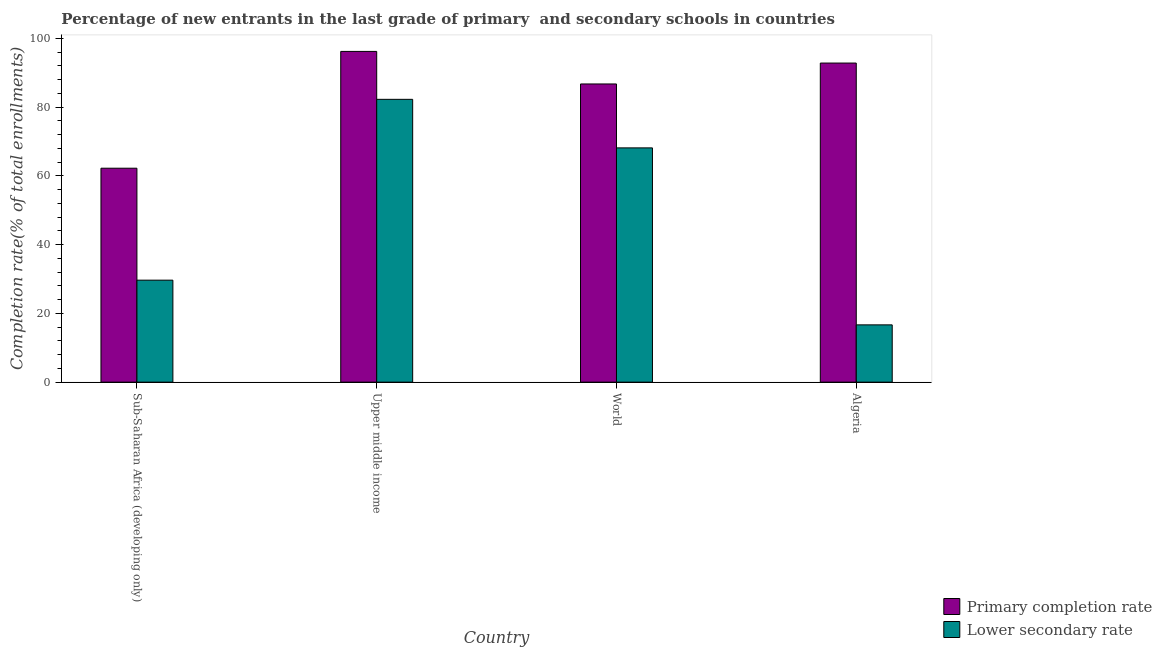How many different coloured bars are there?
Provide a succinct answer. 2. Are the number of bars per tick equal to the number of legend labels?
Give a very brief answer. Yes. What is the label of the 2nd group of bars from the left?
Provide a short and direct response. Upper middle income. What is the completion rate in primary schools in Sub-Saharan Africa (developing only)?
Ensure brevity in your answer.  62.25. Across all countries, what is the maximum completion rate in secondary schools?
Provide a succinct answer. 82.3. Across all countries, what is the minimum completion rate in primary schools?
Ensure brevity in your answer.  62.25. In which country was the completion rate in secondary schools maximum?
Provide a short and direct response. Upper middle income. In which country was the completion rate in secondary schools minimum?
Your answer should be very brief. Algeria. What is the total completion rate in primary schools in the graph?
Provide a succinct answer. 338.13. What is the difference between the completion rate in primary schools in Algeria and that in Sub-Saharan Africa (developing only)?
Keep it short and to the point. 30.6. What is the difference between the completion rate in secondary schools in Sub-Saharan Africa (developing only) and the completion rate in primary schools in World?
Make the answer very short. -57.1. What is the average completion rate in secondary schools per country?
Ensure brevity in your answer.  49.2. What is the difference between the completion rate in primary schools and completion rate in secondary schools in Upper middle income?
Offer a very short reply. 13.95. What is the ratio of the completion rate in secondary schools in Algeria to that in Upper middle income?
Provide a short and direct response. 0.2. Is the difference between the completion rate in secondary schools in Algeria and Sub-Saharan Africa (developing only) greater than the difference between the completion rate in primary schools in Algeria and Sub-Saharan Africa (developing only)?
Provide a short and direct response. No. What is the difference between the highest and the second highest completion rate in primary schools?
Offer a very short reply. 3.39. What is the difference between the highest and the lowest completion rate in secondary schools?
Your answer should be compact. 65.63. In how many countries, is the completion rate in secondary schools greater than the average completion rate in secondary schools taken over all countries?
Provide a short and direct response. 2. Is the sum of the completion rate in primary schools in Sub-Saharan Africa (developing only) and Upper middle income greater than the maximum completion rate in secondary schools across all countries?
Make the answer very short. Yes. What does the 1st bar from the left in World represents?
Your response must be concise. Primary completion rate. What does the 2nd bar from the right in World represents?
Your answer should be compact. Primary completion rate. How many countries are there in the graph?
Your answer should be very brief. 4. Where does the legend appear in the graph?
Provide a short and direct response. Bottom right. How many legend labels are there?
Offer a terse response. 2. What is the title of the graph?
Your answer should be compact. Percentage of new entrants in the last grade of primary  and secondary schools in countries. Does "Taxes" appear as one of the legend labels in the graph?
Provide a short and direct response. No. What is the label or title of the X-axis?
Give a very brief answer. Country. What is the label or title of the Y-axis?
Provide a succinct answer. Completion rate(% of total enrollments). What is the Completion rate(% of total enrollments) in Primary completion rate in Sub-Saharan Africa (developing only)?
Your answer should be compact. 62.25. What is the Completion rate(% of total enrollments) in Lower secondary rate in Sub-Saharan Africa (developing only)?
Offer a very short reply. 29.68. What is the Completion rate(% of total enrollments) of Primary completion rate in Upper middle income?
Offer a very short reply. 96.24. What is the Completion rate(% of total enrollments) of Lower secondary rate in Upper middle income?
Provide a short and direct response. 82.3. What is the Completion rate(% of total enrollments) in Primary completion rate in World?
Provide a succinct answer. 86.77. What is the Completion rate(% of total enrollments) in Lower secondary rate in World?
Give a very brief answer. 68.17. What is the Completion rate(% of total enrollments) of Primary completion rate in Algeria?
Keep it short and to the point. 92.86. What is the Completion rate(% of total enrollments) in Lower secondary rate in Algeria?
Offer a terse response. 16.67. Across all countries, what is the maximum Completion rate(% of total enrollments) in Primary completion rate?
Make the answer very short. 96.24. Across all countries, what is the maximum Completion rate(% of total enrollments) in Lower secondary rate?
Offer a terse response. 82.3. Across all countries, what is the minimum Completion rate(% of total enrollments) in Primary completion rate?
Keep it short and to the point. 62.25. Across all countries, what is the minimum Completion rate(% of total enrollments) of Lower secondary rate?
Give a very brief answer. 16.67. What is the total Completion rate(% of total enrollments) of Primary completion rate in the graph?
Ensure brevity in your answer.  338.13. What is the total Completion rate(% of total enrollments) of Lower secondary rate in the graph?
Offer a very short reply. 196.82. What is the difference between the Completion rate(% of total enrollments) in Primary completion rate in Sub-Saharan Africa (developing only) and that in Upper middle income?
Give a very brief answer. -33.99. What is the difference between the Completion rate(% of total enrollments) in Lower secondary rate in Sub-Saharan Africa (developing only) and that in Upper middle income?
Make the answer very short. -52.62. What is the difference between the Completion rate(% of total enrollments) in Primary completion rate in Sub-Saharan Africa (developing only) and that in World?
Give a very brief answer. -24.52. What is the difference between the Completion rate(% of total enrollments) of Lower secondary rate in Sub-Saharan Africa (developing only) and that in World?
Keep it short and to the point. -38.5. What is the difference between the Completion rate(% of total enrollments) of Primary completion rate in Sub-Saharan Africa (developing only) and that in Algeria?
Provide a short and direct response. -30.6. What is the difference between the Completion rate(% of total enrollments) in Lower secondary rate in Sub-Saharan Africa (developing only) and that in Algeria?
Give a very brief answer. 13.01. What is the difference between the Completion rate(% of total enrollments) in Primary completion rate in Upper middle income and that in World?
Your response must be concise. 9.47. What is the difference between the Completion rate(% of total enrollments) in Lower secondary rate in Upper middle income and that in World?
Keep it short and to the point. 14.13. What is the difference between the Completion rate(% of total enrollments) in Primary completion rate in Upper middle income and that in Algeria?
Keep it short and to the point. 3.39. What is the difference between the Completion rate(% of total enrollments) of Lower secondary rate in Upper middle income and that in Algeria?
Ensure brevity in your answer.  65.63. What is the difference between the Completion rate(% of total enrollments) in Primary completion rate in World and that in Algeria?
Give a very brief answer. -6.08. What is the difference between the Completion rate(% of total enrollments) of Lower secondary rate in World and that in Algeria?
Offer a very short reply. 51.5. What is the difference between the Completion rate(% of total enrollments) of Primary completion rate in Sub-Saharan Africa (developing only) and the Completion rate(% of total enrollments) of Lower secondary rate in Upper middle income?
Your answer should be compact. -20.04. What is the difference between the Completion rate(% of total enrollments) of Primary completion rate in Sub-Saharan Africa (developing only) and the Completion rate(% of total enrollments) of Lower secondary rate in World?
Offer a terse response. -5.92. What is the difference between the Completion rate(% of total enrollments) in Primary completion rate in Sub-Saharan Africa (developing only) and the Completion rate(% of total enrollments) in Lower secondary rate in Algeria?
Offer a terse response. 45.58. What is the difference between the Completion rate(% of total enrollments) of Primary completion rate in Upper middle income and the Completion rate(% of total enrollments) of Lower secondary rate in World?
Your answer should be compact. 28.07. What is the difference between the Completion rate(% of total enrollments) in Primary completion rate in Upper middle income and the Completion rate(% of total enrollments) in Lower secondary rate in Algeria?
Your response must be concise. 79.57. What is the difference between the Completion rate(% of total enrollments) of Primary completion rate in World and the Completion rate(% of total enrollments) of Lower secondary rate in Algeria?
Offer a very short reply. 70.1. What is the average Completion rate(% of total enrollments) in Primary completion rate per country?
Ensure brevity in your answer.  84.53. What is the average Completion rate(% of total enrollments) of Lower secondary rate per country?
Provide a succinct answer. 49.2. What is the difference between the Completion rate(% of total enrollments) of Primary completion rate and Completion rate(% of total enrollments) of Lower secondary rate in Sub-Saharan Africa (developing only)?
Ensure brevity in your answer.  32.58. What is the difference between the Completion rate(% of total enrollments) in Primary completion rate and Completion rate(% of total enrollments) in Lower secondary rate in Upper middle income?
Provide a short and direct response. 13.95. What is the difference between the Completion rate(% of total enrollments) of Primary completion rate and Completion rate(% of total enrollments) of Lower secondary rate in World?
Give a very brief answer. 18.6. What is the difference between the Completion rate(% of total enrollments) in Primary completion rate and Completion rate(% of total enrollments) in Lower secondary rate in Algeria?
Offer a very short reply. 76.19. What is the ratio of the Completion rate(% of total enrollments) in Primary completion rate in Sub-Saharan Africa (developing only) to that in Upper middle income?
Make the answer very short. 0.65. What is the ratio of the Completion rate(% of total enrollments) of Lower secondary rate in Sub-Saharan Africa (developing only) to that in Upper middle income?
Make the answer very short. 0.36. What is the ratio of the Completion rate(% of total enrollments) of Primary completion rate in Sub-Saharan Africa (developing only) to that in World?
Your response must be concise. 0.72. What is the ratio of the Completion rate(% of total enrollments) in Lower secondary rate in Sub-Saharan Africa (developing only) to that in World?
Offer a very short reply. 0.44. What is the ratio of the Completion rate(% of total enrollments) of Primary completion rate in Sub-Saharan Africa (developing only) to that in Algeria?
Ensure brevity in your answer.  0.67. What is the ratio of the Completion rate(% of total enrollments) of Lower secondary rate in Sub-Saharan Africa (developing only) to that in Algeria?
Your answer should be compact. 1.78. What is the ratio of the Completion rate(% of total enrollments) in Primary completion rate in Upper middle income to that in World?
Your response must be concise. 1.11. What is the ratio of the Completion rate(% of total enrollments) in Lower secondary rate in Upper middle income to that in World?
Make the answer very short. 1.21. What is the ratio of the Completion rate(% of total enrollments) of Primary completion rate in Upper middle income to that in Algeria?
Your answer should be very brief. 1.04. What is the ratio of the Completion rate(% of total enrollments) in Lower secondary rate in Upper middle income to that in Algeria?
Provide a succinct answer. 4.94. What is the ratio of the Completion rate(% of total enrollments) of Primary completion rate in World to that in Algeria?
Offer a very short reply. 0.93. What is the ratio of the Completion rate(% of total enrollments) of Lower secondary rate in World to that in Algeria?
Make the answer very short. 4.09. What is the difference between the highest and the second highest Completion rate(% of total enrollments) in Primary completion rate?
Ensure brevity in your answer.  3.39. What is the difference between the highest and the second highest Completion rate(% of total enrollments) of Lower secondary rate?
Your answer should be very brief. 14.13. What is the difference between the highest and the lowest Completion rate(% of total enrollments) in Primary completion rate?
Provide a short and direct response. 33.99. What is the difference between the highest and the lowest Completion rate(% of total enrollments) in Lower secondary rate?
Ensure brevity in your answer.  65.63. 